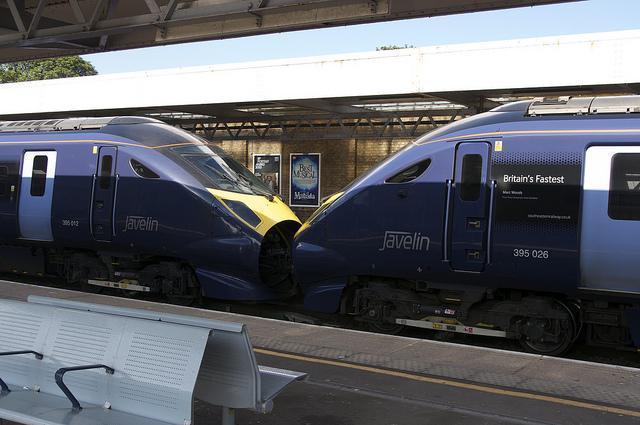How many trains are there?
Give a very brief answer. 2. How many benches can you see?
Give a very brief answer. 2. 